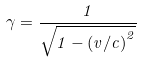<formula> <loc_0><loc_0><loc_500><loc_500>\gamma = { \frac { 1 } { \sqrt { 1 - { ( v / c ) } ^ { 2 } } } }</formula> 